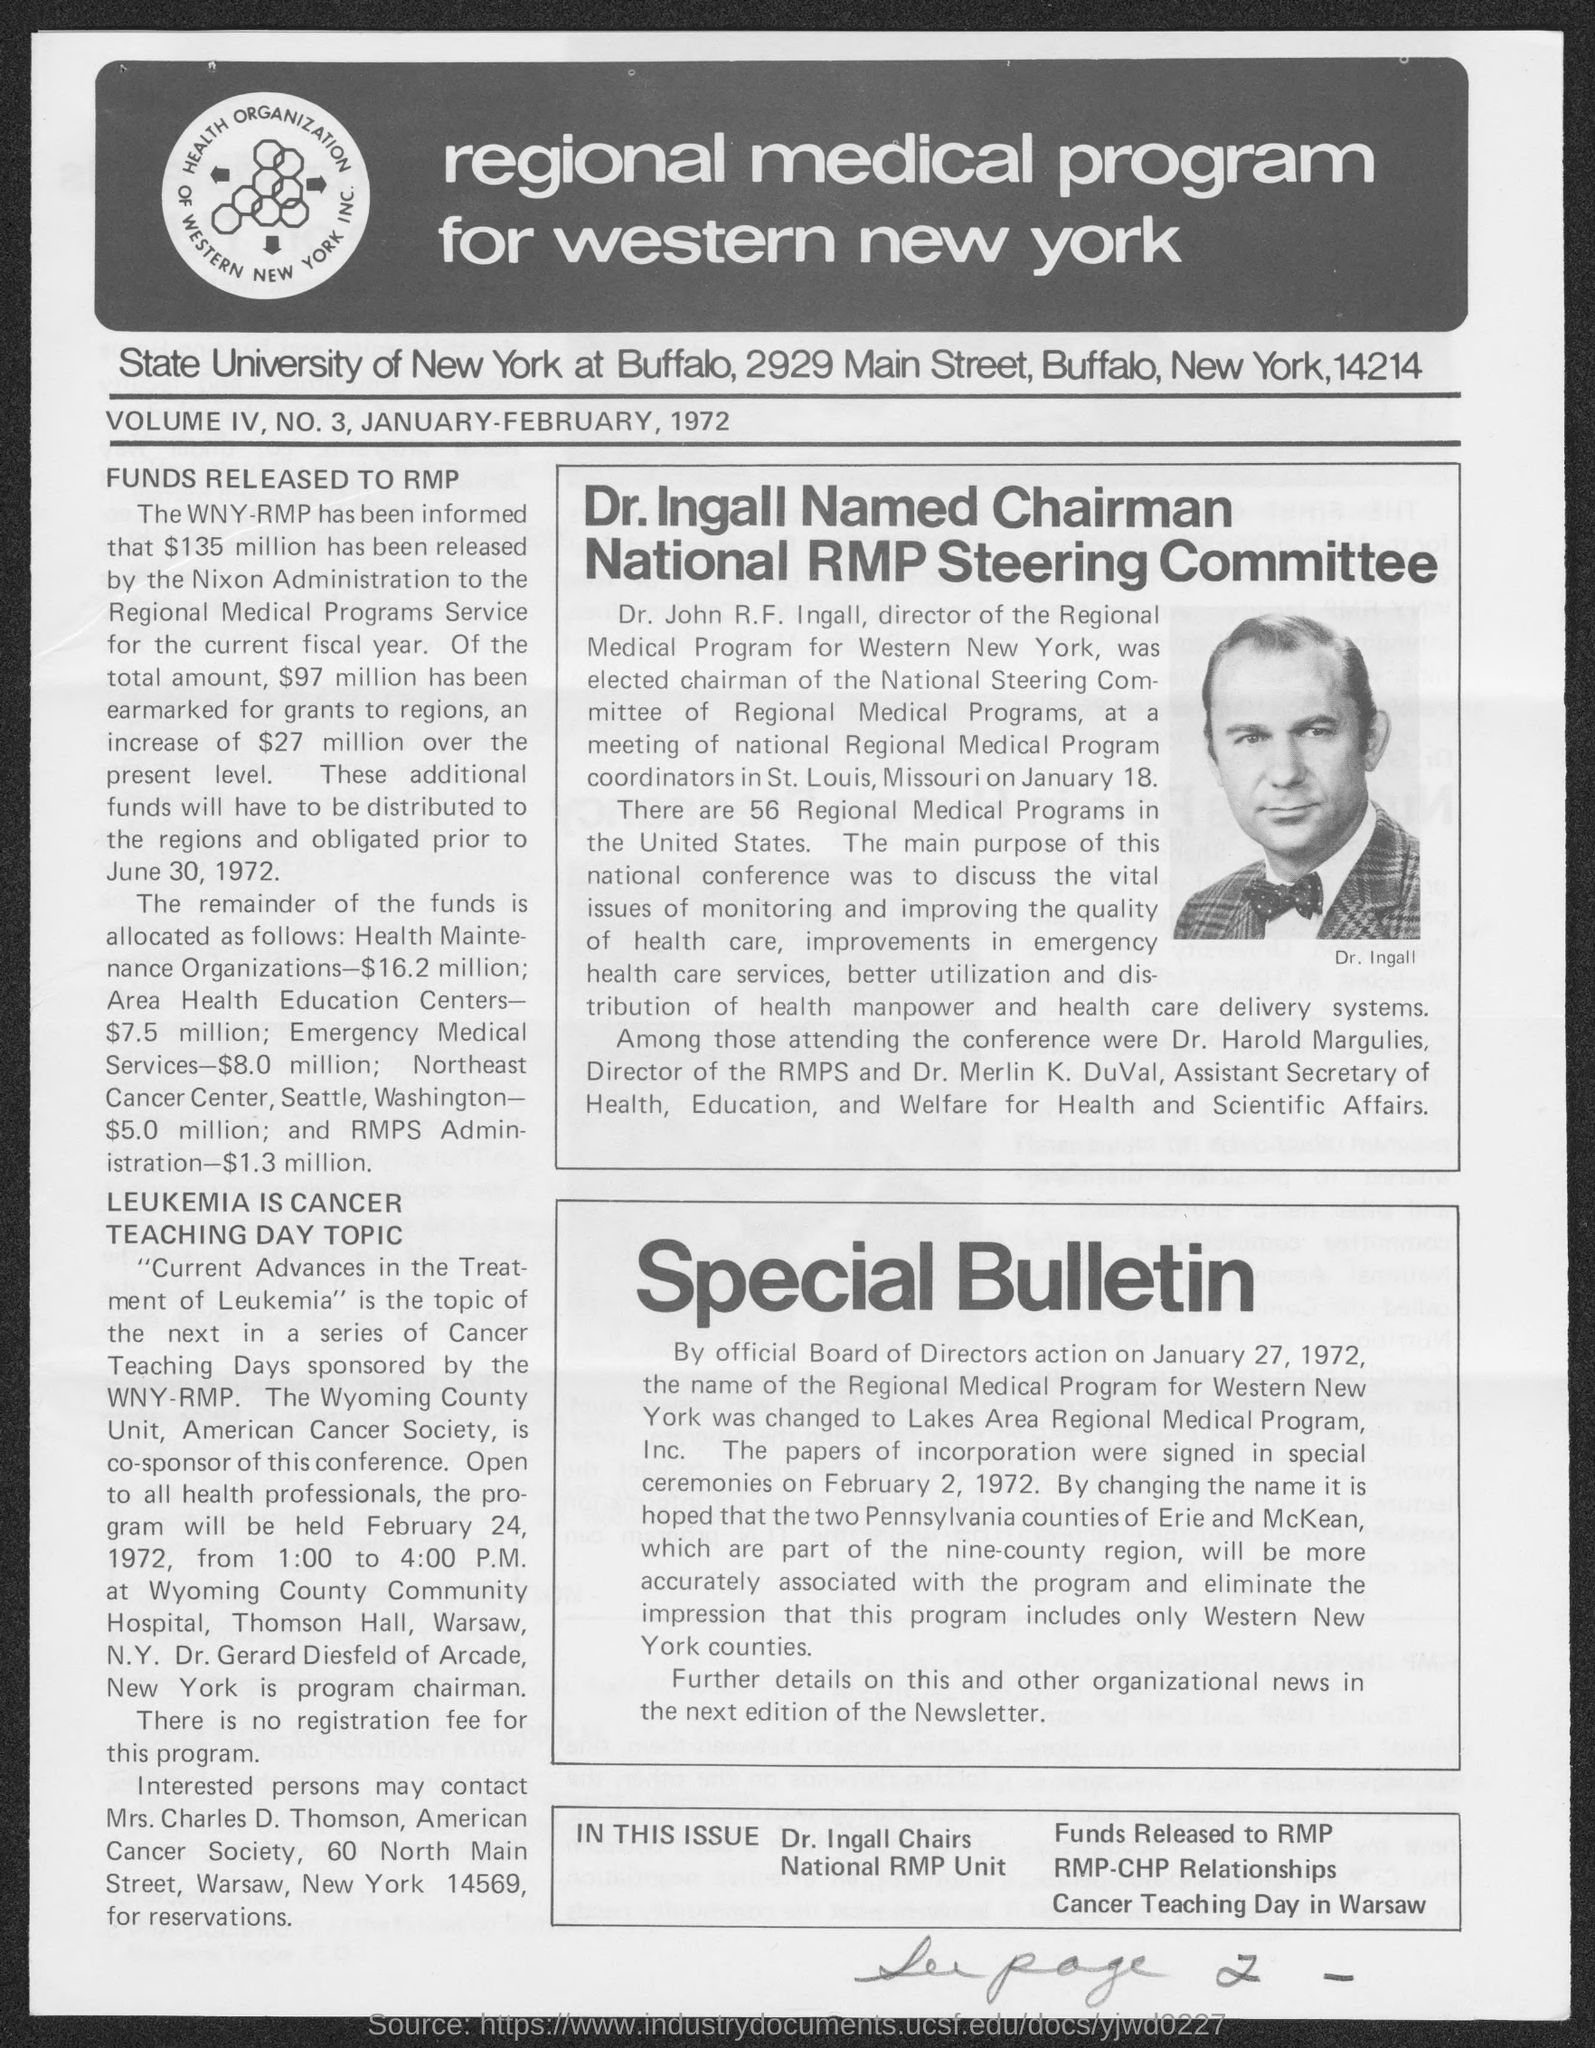In which state is state university of new york located ?
Give a very brief answer. New York. 